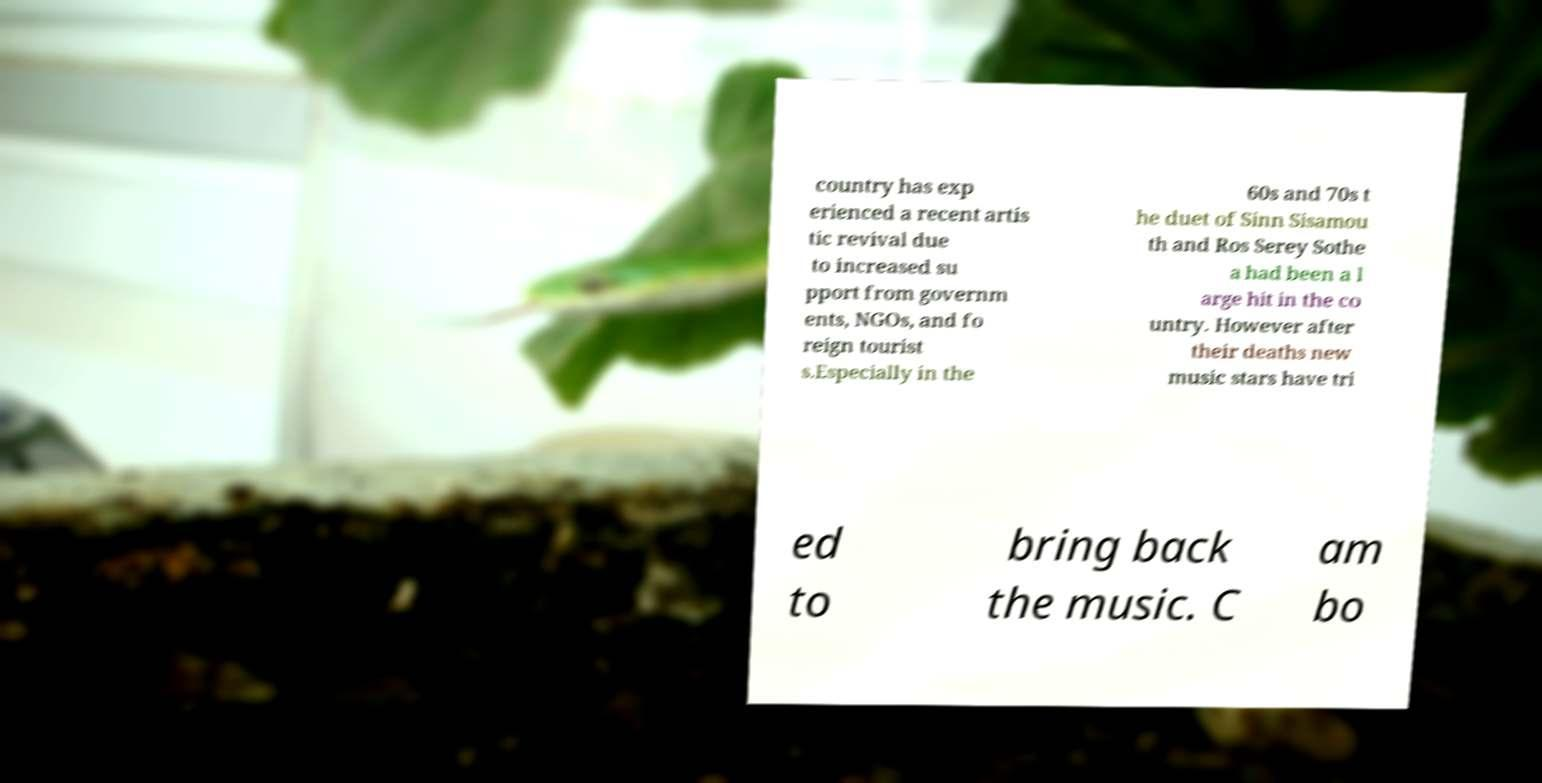Could you assist in decoding the text presented in this image and type it out clearly? country has exp erienced a recent artis tic revival due to increased su pport from governm ents, NGOs, and fo reign tourist s.Especially in the 60s and 70s t he duet of Sinn Sisamou th and Ros Serey Sothe a had been a l arge hit in the co untry. However after their deaths new music stars have tri ed to bring back the music. C am bo 